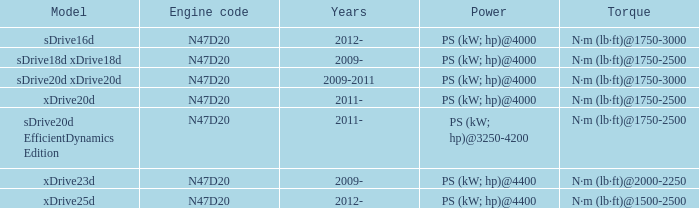What years did the sdrive16d model have a Torque of n·m (lb·ft)@1750-3000? 2012-. Parse the full table. {'header': ['Model', 'Engine code', 'Years', 'Power', 'Torque'], 'rows': [['sDrive16d', 'N47D20', '2012-', 'PS (kW; hp)@4000', 'N·m (lb·ft)@1750-3000'], ['sDrive18d xDrive18d', 'N47D20', '2009-', 'PS (kW; hp)@4000', 'N·m (lb·ft)@1750-2500'], ['sDrive20d xDrive20d', 'N47D20', '2009-2011', 'PS (kW; hp)@4000', 'N·m (lb·ft)@1750-3000'], ['xDrive20d', 'N47D20', '2011-', 'PS (kW; hp)@4000', 'N·m (lb·ft)@1750-2500'], ['sDrive20d EfficientDynamics Edition', 'N47D20', '2011-', 'PS (kW; hp)@3250-4200', 'N·m (lb·ft)@1750-2500'], ['xDrive23d', 'N47D20', '2009-', 'PS (kW; hp)@4400', 'N·m (lb·ft)@2000-2250'], ['xDrive25d', 'N47D20', '2012-', 'PS (kW; hp)@4400', 'N·m (lb·ft)@1500-2500']]} 